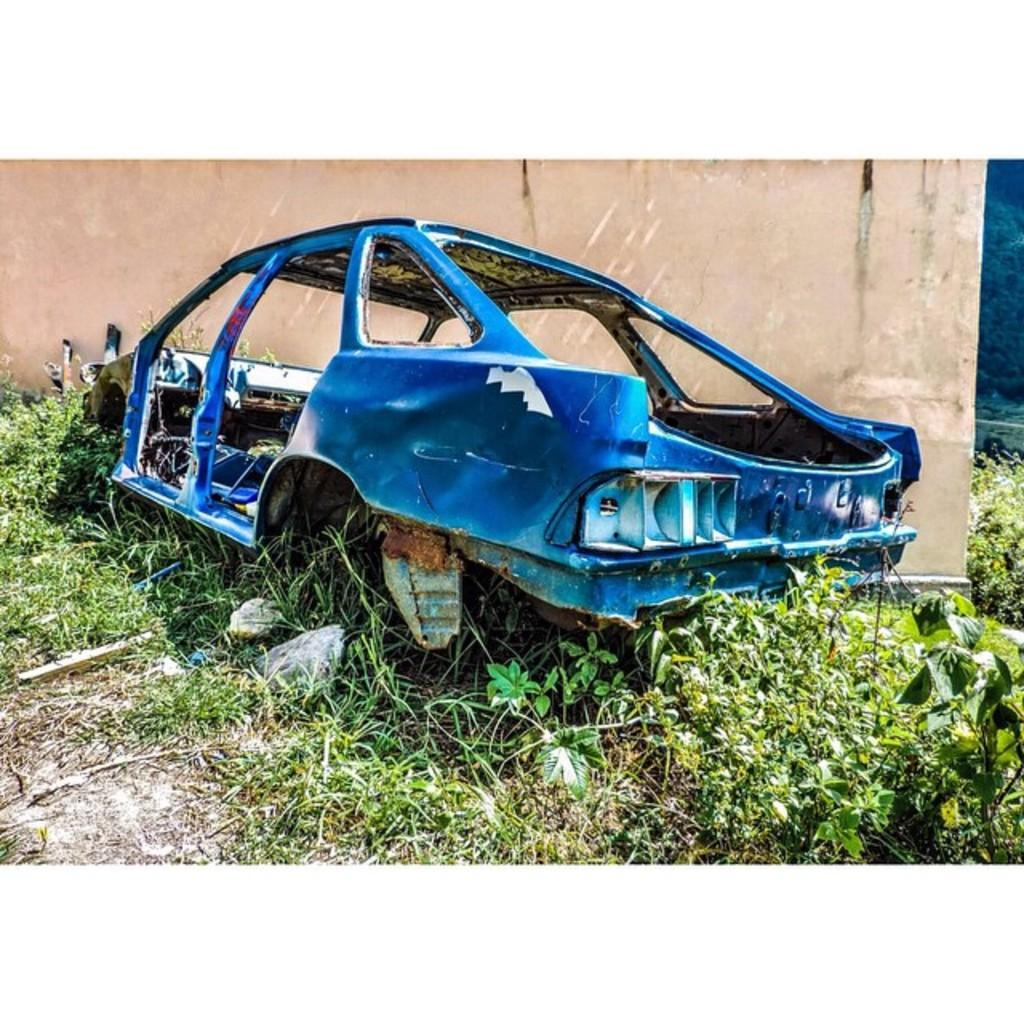What is the main object on the ground in the image? There is a car frame on the ground in the image. What type of vegetation can be seen in the image? Plants and grass are visible in the image. What is the background of the image? There is a wall in the image. How many beds can be seen in the image? There are no beds present in the image. What type of fork is being used to play the guitar in the image? There is no fork or guitar present in the image. 